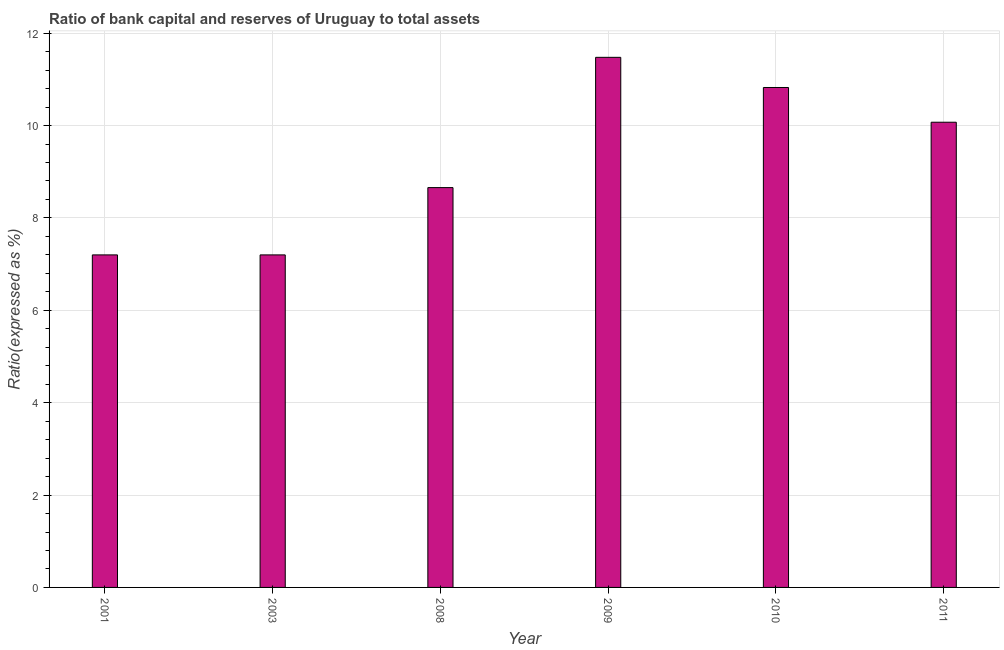Does the graph contain grids?
Offer a terse response. Yes. What is the title of the graph?
Offer a terse response. Ratio of bank capital and reserves of Uruguay to total assets. What is the label or title of the Y-axis?
Offer a very short reply. Ratio(expressed as %). What is the bank capital to assets ratio in 2009?
Give a very brief answer. 11.48. Across all years, what is the maximum bank capital to assets ratio?
Offer a terse response. 11.48. Across all years, what is the minimum bank capital to assets ratio?
Your answer should be very brief. 7.2. In which year was the bank capital to assets ratio maximum?
Your answer should be very brief. 2009. In which year was the bank capital to assets ratio minimum?
Provide a succinct answer. 2001. What is the sum of the bank capital to assets ratio?
Make the answer very short. 55.43. What is the difference between the bank capital to assets ratio in 2003 and 2008?
Your answer should be very brief. -1.46. What is the average bank capital to assets ratio per year?
Offer a very short reply. 9.24. What is the median bank capital to assets ratio?
Your response must be concise. 9.36. In how many years, is the bank capital to assets ratio greater than 0.4 %?
Give a very brief answer. 6. Do a majority of the years between 2003 and 2008 (inclusive) have bank capital to assets ratio greater than 2.8 %?
Ensure brevity in your answer.  Yes. What is the ratio of the bank capital to assets ratio in 2010 to that in 2011?
Keep it short and to the point. 1.07. Is the difference between the bank capital to assets ratio in 2008 and 2010 greater than the difference between any two years?
Ensure brevity in your answer.  No. What is the difference between the highest and the second highest bank capital to assets ratio?
Offer a very short reply. 0.65. Is the sum of the bank capital to assets ratio in 2003 and 2008 greater than the maximum bank capital to assets ratio across all years?
Your response must be concise. Yes. What is the difference between the highest and the lowest bank capital to assets ratio?
Your answer should be compact. 4.28. In how many years, is the bank capital to assets ratio greater than the average bank capital to assets ratio taken over all years?
Keep it short and to the point. 3. Are the values on the major ticks of Y-axis written in scientific E-notation?
Make the answer very short. No. What is the Ratio(expressed as %) of 2008?
Provide a short and direct response. 8.66. What is the Ratio(expressed as %) in 2009?
Provide a succinct answer. 11.48. What is the Ratio(expressed as %) in 2010?
Keep it short and to the point. 10.82. What is the Ratio(expressed as %) of 2011?
Make the answer very short. 10.07. What is the difference between the Ratio(expressed as %) in 2001 and 2008?
Your answer should be compact. -1.46. What is the difference between the Ratio(expressed as %) in 2001 and 2009?
Provide a short and direct response. -4.28. What is the difference between the Ratio(expressed as %) in 2001 and 2010?
Your answer should be very brief. -3.62. What is the difference between the Ratio(expressed as %) in 2001 and 2011?
Ensure brevity in your answer.  -2.87. What is the difference between the Ratio(expressed as %) in 2003 and 2008?
Make the answer very short. -1.46. What is the difference between the Ratio(expressed as %) in 2003 and 2009?
Make the answer very short. -4.28. What is the difference between the Ratio(expressed as %) in 2003 and 2010?
Give a very brief answer. -3.62. What is the difference between the Ratio(expressed as %) in 2003 and 2011?
Make the answer very short. -2.87. What is the difference between the Ratio(expressed as %) in 2008 and 2009?
Provide a short and direct response. -2.82. What is the difference between the Ratio(expressed as %) in 2008 and 2010?
Give a very brief answer. -2.17. What is the difference between the Ratio(expressed as %) in 2008 and 2011?
Offer a very short reply. -1.42. What is the difference between the Ratio(expressed as %) in 2009 and 2010?
Provide a succinct answer. 0.65. What is the difference between the Ratio(expressed as %) in 2009 and 2011?
Provide a short and direct response. 1.41. What is the difference between the Ratio(expressed as %) in 2010 and 2011?
Give a very brief answer. 0.75. What is the ratio of the Ratio(expressed as %) in 2001 to that in 2008?
Ensure brevity in your answer.  0.83. What is the ratio of the Ratio(expressed as %) in 2001 to that in 2009?
Your answer should be very brief. 0.63. What is the ratio of the Ratio(expressed as %) in 2001 to that in 2010?
Offer a terse response. 0.67. What is the ratio of the Ratio(expressed as %) in 2001 to that in 2011?
Make the answer very short. 0.71. What is the ratio of the Ratio(expressed as %) in 2003 to that in 2008?
Offer a very short reply. 0.83. What is the ratio of the Ratio(expressed as %) in 2003 to that in 2009?
Offer a terse response. 0.63. What is the ratio of the Ratio(expressed as %) in 2003 to that in 2010?
Give a very brief answer. 0.67. What is the ratio of the Ratio(expressed as %) in 2003 to that in 2011?
Your response must be concise. 0.71. What is the ratio of the Ratio(expressed as %) in 2008 to that in 2009?
Offer a terse response. 0.75. What is the ratio of the Ratio(expressed as %) in 2008 to that in 2011?
Keep it short and to the point. 0.86. What is the ratio of the Ratio(expressed as %) in 2009 to that in 2010?
Give a very brief answer. 1.06. What is the ratio of the Ratio(expressed as %) in 2009 to that in 2011?
Offer a terse response. 1.14. What is the ratio of the Ratio(expressed as %) in 2010 to that in 2011?
Make the answer very short. 1.07. 